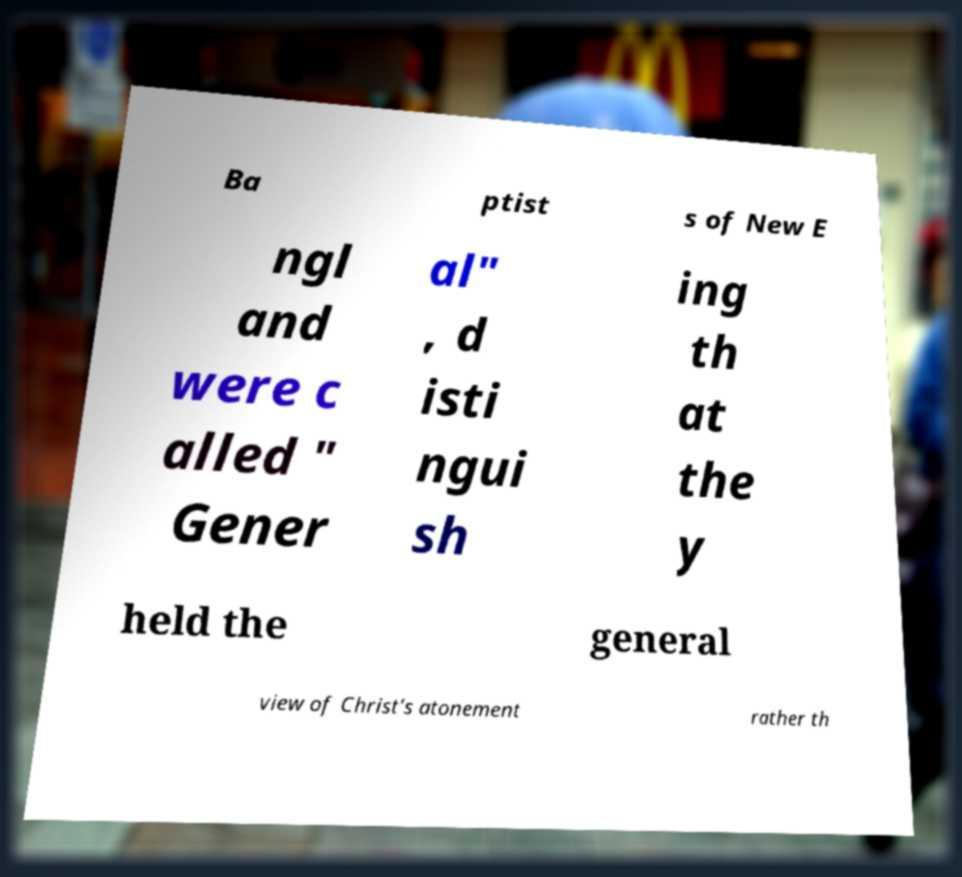Can you accurately transcribe the text from the provided image for me? Ba ptist s of New E ngl and were c alled " Gener al" , d isti ngui sh ing th at the y held the general view of Christ's atonement rather th 